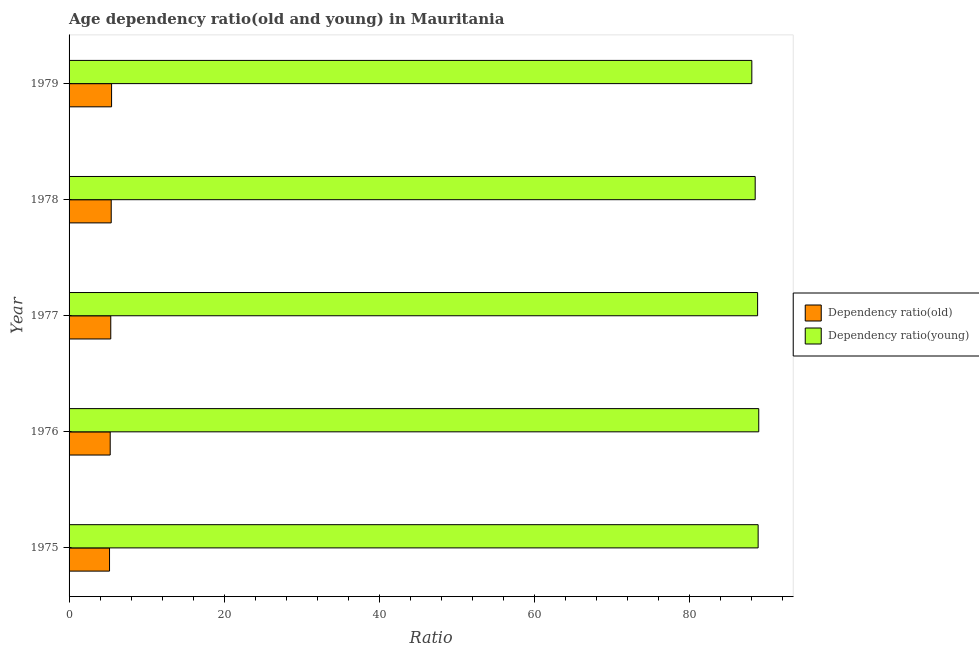How many different coloured bars are there?
Provide a succinct answer. 2. How many groups of bars are there?
Your answer should be very brief. 5. Are the number of bars per tick equal to the number of legend labels?
Offer a very short reply. Yes. How many bars are there on the 4th tick from the top?
Provide a succinct answer. 2. How many bars are there on the 5th tick from the bottom?
Provide a short and direct response. 2. What is the label of the 5th group of bars from the top?
Your answer should be compact. 1975. In how many cases, is the number of bars for a given year not equal to the number of legend labels?
Give a very brief answer. 0. What is the age dependency ratio(young) in 1976?
Give a very brief answer. 88.97. Across all years, what is the maximum age dependency ratio(old)?
Provide a short and direct response. 5.48. Across all years, what is the minimum age dependency ratio(old)?
Offer a terse response. 5.22. In which year was the age dependency ratio(young) maximum?
Make the answer very short. 1976. In which year was the age dependency ratio(young) minimum?
Offer a very short reply. 1979. What is the total age dependency ratio(young) in the graph?
Offer a very short reply. 443.29. What is the difference between the age dependency ratio(young) in 1975 and that in 1978?
Your answer should be compact. 0.38. What is the difference between the age dependency ratio(young) in 1975 and the age dependency ratio(old) in 1977?
Your answer should be very brief. 83.52. What is the average age dependency ratio(old) per year?
Offer a very short reply. 5.37. In the year 1977, what is the difference between the age dependency ratio(young) and age dependency ratio(old)?
Offer a terse response. 83.45. In how many years, is the age dependency ratio(young) greater than 76 ?
Make the answer very short. 5. Is the age dependency ratio(young) in 1977 less than that in 1979?
Your response must be concise. No. Is the difference between the age dependency ratio(old) in 1977 and 1978 greater than the difference between the age dependency ratio(young) in 1977 and 1978?
Your answer should be very brief. No. What is the difference between the highest and the second highest age dependency ratio(young)?
Offer a terse response. 0.08. What is the difference between the highest and the lowest age dependency ratio(old)?
Ensure brevity in your answer.  0.27. In how many years, is the age dependency ratio(young) greater than the average age dependency ratio(young) taken over all years?
Provide a succinct answer. 3. Is the sum of the age dependency ratio(young) in 1976 and 1978 greater than the maximum age dependency ratio(old) across all years?
Provide a succinct answer. Yes. What does the 1st bar from the top in 1979 represents?
Ensure brevity in your answer.  Dependency ratio(young). What does the 2nd bar from the bottom in 1976 represents?
Offer a very short reply. Dependency ratio(young). What is the difference between two consecutive major ticks on the X-axis?
Your answer should be very brief. 20. Are the values on the major ticks of X-axis written in scientific E-notation?
Keep it short and to the point. No. How many legend labels are there?
Provide a short and direct response. 2. What is the title of the graph?
Provide a short and direct response. Age dependency ratio(old and young) in Mauritania. Does "Arms exports" appear as one of the legend labels in the graph?
Your answer should be compact. No. What is the label or title of the X-axis?
Your answer should be compact. Ratio. What is the label or title of the Y-axis?
Make the answer very short. Year. What is the Ratio of Dependency ratio(old) in 1975?
Your answer should be very brief. 5.22. What is the Ratio of Dependency ratio(young) in 1975?
Your response must be concise. 88.9. What is the Ratio in Dependency ratio(old) in 1976?
Keep it short and to the point. 5.31. What is the Ratio of Dependency ratio(young) in 1976?
Offer a terse response. 88.97. What is the Ratio in Dependency ratio(old) in 1977?
Your answer should be compact. 5.38. What is the Ratio of Dependency ratio(young) in 1977?
Make the answer very short. 88.83. What is the Ratio in Dependency ratio(old) in 1978?
Provide a short and direct response. 5.44. What is the Ratio in Dependency ratio(young) in 1978?
Make the answer very short. 88.52. What is the Ratio of Dependency ratio(old) in 1979?
Ensure brevity in your answer.  5.48. What is the Ratio of Dependency ratio(young) in 1979?
Your answer should be very brief. 88.08. Across all years, what is the maximum Ratio in Dependency ratio(old)?
Your answer should be compact. 5.48. Across all years, what is the maximum Ratio in Dependency ratio(young)?
Ensure brevity in your answer.  88.97. Across all years, what is the minimum Ratio of Dependency ratio(old)?
Give a very brief answer. 5.22. Across all years, what is the minimum Ratio of Dependency ratio(young)?
Offer a very short reply. 88.08. What is the total Ratio in Dependency ratio(old) in the graph?
Offer a very short reply. 26.83. What is the total Ratio in Dependency ratio(young) in the graph?
Your answer should be compact. 443.29. What is the difference between the Ratio in Dependency ratio(old) in 1975 and that in 1976?
Give a very brief answer. -0.09. What is the difference between the Ratio in Dependency ratio(young) in 1975 and that in 1976?
Make the answer very short. -0.08. What is the difference between the Ratio of Dependency ratio(old) in 1975 and that in 1977?
Offer a terse response. -0.16. What is the difference between the Ratio of Dependency ratio(young) in 1975 and that in 1977?
Your response must be concise. 0.07. What is the difference between the Ratio of Dependency ratio(old) in 1975 and that in 1978?
Give a very brief answer. -0.22. What is the difference between the Ratio of Dependency ratio(young) in 1975 and that in 1978?
Your response must be concise. 0.38. What is the difference between the Ratio of Dependency ratio(old) in 1975 and that in 1979?
Make the answer very short. -0.27. What is the difference between the Ratio in Dependency ratio(young) in 1975 and that in 1979?
Offer a very short reply. 0.82. What is the difference between the Ratio of Dependency ratio(old) in 1976 and that in 1977?
Provide a succinct answer. -0.07. What is the difference between the Ratio of Dependency ratio(young) in 1976 and that in 1977?
Your response must be concise. 0.15. What is the difference between the Ratio of Dependency ratio(old) in 1976 and that in 1978?
Provide a succinct answer. -0.13. What is the difference between the Ratio in Dependency ratio(young) in 1976 and that in 1978?
Your answer should be very brief. 0.46. What is the difference between the Ratio of Dependency ratio(old) in 1976 and that in 1979?
Your response must be concise. -0.18. What is the difference between the Ratio of Dependency ratio(young) in 1976 and that in 1979?
Provide a succinct answer. 0.89. What is the difference between the Ratio in Dependency ratio(old) in 1977 and that in 1978?
Your answer should be very brief. -0.06. What is the difference between the Ratio in Dependency ratio(young) in 1977 and that in 1978?
Your response must be concise. 0.31. What is the difference between the Ratio in Dependency ratio(old) in 1977 and that in 1979?
Offer a very short reply. -0.11. What is the difference between the Ratio of Dependency ratio(young) in 1977 and that in 1979?
Keep it short and to the point. 0.75. What is the difference between the Ratio of Dependency ratio(old) in 1978 and that in 1979?
Ensure brevity in your answer.  -0.05. What is the difference between the Ratio of Dependency ratio(young) in 1978 and that in 1979?
Ensure brevity in your answer.  0.43. What is the difference between the Ratio of Dependency ratio(old) in 1975 and the Ratio of Dependency ratio(young) in 1976?
Provide a short and direct response. -83.75. What is the difference between the Ratio in Dependency ratio(old) in 1975 and the Ratio in Dependency ratio(young) in 1977?
Your answer should be very brief. -83.61. What is the difference between the Ratio in Dependency ratio(old) in 1975 and the Ratio in Dependency ratio(young) in 1978?
Make the answer very short. -83.3. What is the difference between the Ratio of Dependency ratio(old) in 1975 and the Ratio of Dependency ratio(young) in 1979?
Give a very brief answer. -82.86. What is the difference between the Ratio in Dependency ratio(old) in 1976 and the Ratio in Dependency ratio(young) in 1977?
Keep it short and to the point. -83.52. What is the difference between the Ratio in Dependency ratio(old) in 1976 and the Ratio in Dependency ratio(young) in 1978?
Your answer should be very brief. -83.21. What is the difference between the Ratio in Dependency ratio(old) in 1976 and the Ratio in Dependency ratio(young) in 1979?
Ensure brevity in your answer.  -82.77. What is the difference between the Ratio in Dependency ratio(old) in 1977 and the Ratio in Dependency ratio(young) in 1978?
Your answer should be very brief. -83.14. What is the difference between the Ratio in Dependency ratio(old) in 1977 and the Ratio in Dependency ratio(young) in 1979?
Offer a terse response. -82.7. What is the difference between the Ratio of Dependency ratio(old) in 1978 and the Ratio of Dependency ratio(young) in 1979?
Your response must be concise. -82.64. What is the average Ratio of Dependency ratio(old) per year?
Your answer should be compact. 5.37. What is the average Ratio of Dependency ratio(young) per year?
Provide a succinct answer. 88.66. In the year 1975, what is the difference between the Ratio of Dependency ratio(old) and Ratio of Dependency ratio(young)?
Provide a short and direct response. -83.68. In the year 1976, what is the difference between the Ratio in Dependency ratio(old) and Ratio in Dependency ratio(young)?
Give a very brief answer. -83.67. In the year 1977, what is the difference between the Ratio of Dependency ratio(old) and Ratio of Dependency ratio(young)?
Provide a succinct answer. -83.45. In the year 1978, what is the difference between the Ratio of Dependency ratio(old) and Ratio of Dependency ratio(young)?
Keep it short and to the point. -83.08. In the year 1979, what is the difference between the Ratio of Dependency ratio(old) and Ratio of Dependency ratio(young)?
Make the answer very short. -82.6. What is the ratio of the Ratio of Dependency ratio(old) in 1975 to that in 1976?
Keep it short and to the point. 0.98. What is the ratio of the Ratio of Dependency ratio(young) in 1975 to that in 1976?
Offer a very short reply. 1. What is the ratio of the Ratio in Dependency ratio(old) in 1975 to that in 1977?
Your answer should be compact. 0.97. What is the ratio of the Ratio of Dependency ratio(young) in 1975 to that in 1977?
Offer a very short reply. 1. What is the ratio of the Ratio of Dependency ratio(old) in 1975 to that in 1978?
Ensure brevity in your answer.  0.96. What is the ratio of the Ratio of Dependency ratio(old) in 1975 to that in 1979?
Keep it short and to the point. 0.95. What is the ratio of the Ratio in Dependency ratio(young) in 1975 to that in 1979?
Offer a very short reply. 1.01. What is the ratio of the Ratio in Dependency ratio(old) in 1976 to that in 1977?
Provide a succinct answer. 0.99. What is the ratio of the Ratio in Dependency ratio(young) in 1976 to that in 1977?
Keep it short and to the point. 1. What is the ratio of the Ratio of Dependency ratio(old) in 1976 to that in 1978?
Your response must be concise. 0.98. What is the ratio of the Ratio of Dependency ratio(young) in 1976 to that in 1978?
Ensure brevity in your answer.  1.01. What is the ratio of the Ratio of Dependency ratio(old) in 1976 to that in 1979?
Keep it short and to the point. 0.97. What is the ratio of the Ratio in Dependency ratio(young) in 1976 to that in 1979?
Keep it short and to the point. 1.01. What is the ratio of the Ratio of Dependency ratio(old) in 1977 to that in 1979?
Your answer should be compact. 0.98. What is the ratio of the Ratio of Dependency ratio(young) in 1977 to that in 1979?
Make the answer very short. 1.01. What is the ratio of the Ratio of Dependency ratio(old) in 1978 to that in 1979?
Make the answer very short. 0.99. What is the ratio of the Ratio of Dependency ratio(young) in 1978 to that in 1979?
Keep it short and to the point. 1. What is the difference between the highest and the second highest Ratio of Dependency ratio(old)?
Provide a succinct answer. 0.05. What is the difference between the highest and the second highest Ratio of Dependency ratio(young)?
Offer a very short reply. 0.08. What is the difference between the highest and the lowest Ratio of Dependency ratio(old)?
Your response must be concise. 0.27. What is the difference between the highest and the lowest Ratio in Dependency ratio(young)?
Provide a short and direct response. 0.89. 